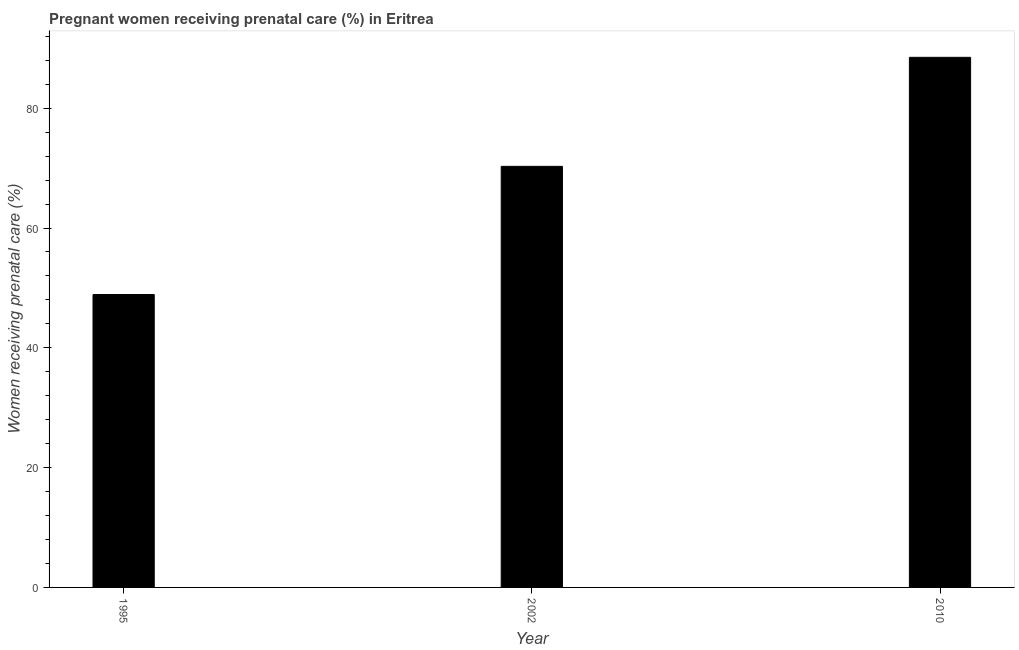What is the title of the graph?
Offer a very short reply. Pregnant women receiving prenatal care (%) in Eritrea. What is the label or title of the X-axis?
Keep it short and to the point. Year. What is the label or title of the Y-axis?
Keep it short and to the point. Women receiving prenatal care (%). What is the percentage of pregnant women receiving prenatal care in 2002?
Give a very brief answer. 70.3. Across all years, what is the maximum percentage of pregnant women receiving prenatal care?
Offer a very short reply. 88.5. Across all years, what is the minimum percentage of pregnant women receiving prenatal care?
Provide a succinct answer. 48.9. In which year was the percentage of pregnant women receiving prenatal care minimum?
Provide a succinct answer. 1995. What is the sum of the percentage of pregnant women receiving prenatal care?
Offer a terse response. 207.7. What is the difference between the percentage of pregnant women receiving prenatal care in 1995 and 2010?
Provide a succinct answer. -39.6. What is the average percentage of pregnant women receiving prenatal care per year?
Provide a short and direct response. 69.23. What is the median percentage of pregnant women receiving prenatal care?
Your response must be concise. 70.3. In how many years, is the percentage of pregnant women receiving prenatal care greater than 84 %?
Provide a short and direct response. 1. Do a majority of the years between 2002 and 2010 (inclusive) have percentage of pregnant women receiving prenatal care greater than 84 %?
Your response must be concise. No. What is the ratio of the percentage of pregnant women receiving prenatal care in 2002 to that in 2010?
Your answer should be very brief. 0.79. Is the difference between the percentage of pregnant women receiving prenatal care in 2002 and 2010 greater than the difference between any two years?
Give a very brief answer. No. Is the sum of the percentage of pregnant women receiving prenatal care in 1995 and 2002 greater than the maximum percentage of pregnant women receiving prenatal care across all years?
Your answer should be very brief. Yes. What is the difference between the highest and the lowest percentage of pregnant women receiving prenatal care?
Your answer should be very brief. 39.6. In how many years, is the percentage of pregnant women receiving prenatal care greater than the average percentage of pregnant women receiving prenatal care taken over all years?
Keep it short and to the point. 2. How many bars are there?
Offer a very short reply. 3. Are all the bars in the graph horizontal?
Provide a short and direct response. No. What is the Women receiving prenatal care (%) of 1995?
Offer a very short reply. 48.9. What is the Women receiving prenatal care (%) in 2002?
Your answer should be compact. 70.3. What is the Women receiving prenatal care (%) of 2010?
Give a very brief answer. 88.5. What is the difference between the Women receiving prenatal care (%) in 1995 and 2002?
Provide a succinct answer. -21.4. What is the difference between the Women receiving prenatal care (%) in 1995 and 2010?
Ensure brevity in your answer.  -39.6. What is the difference between the Women receiving prenatal care (%) in 2002 and 2010?
Your answer should be compact. -18.2. What is the ratio of the Women receiving prenatal care (%) in 1995 to that in 2002?
Your answer should be compact. 0.7. What is the ratio of the Women receiving prenatal care (%) in 1995 to that in 2010?
Offer a very short reply. 0.55. What is the ratio of the Women receiving prenatal care (%) in 2002 to that in 2010?
Provide a succinct answer. 0.79. 